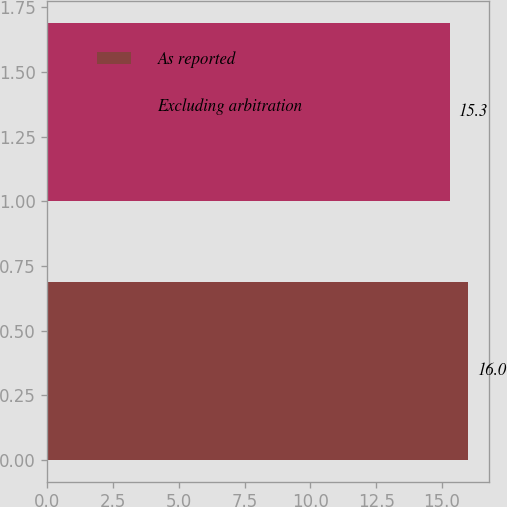Convert chart. <chart><loc_0><loc_0><loc_500><loc_500><bar_chart><fcel>As reported<fcel>Excluding arbitration<nl><fcel>16<fcel>15.3<nl></chart> 